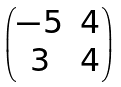Convert formula to latex. <formula><loc_0><loc_0><loc_500><loc_500>\begin{pmatrix} - 5 & 4 \\ 3 & 4 \end{pmatrix}</formula> 